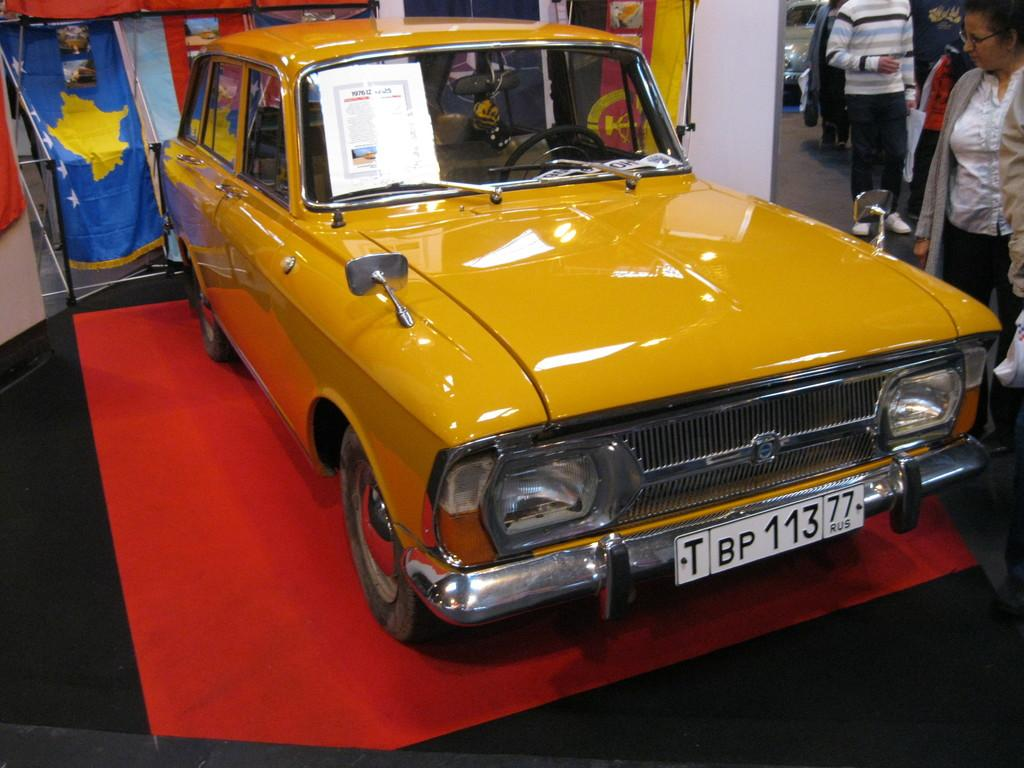What is the car placed on in the image? The car is on a red carpet in the image. What is attached to the car? There is a poster on the car. What can be seen in the background of the image? There are flags in the background. Where are the people located in the image? The people are on the right side of the image. What type of game is being played on the car in the image? There is no game being played on the car in the image. Where is the pot located in the image? There is no pot present in the image. 